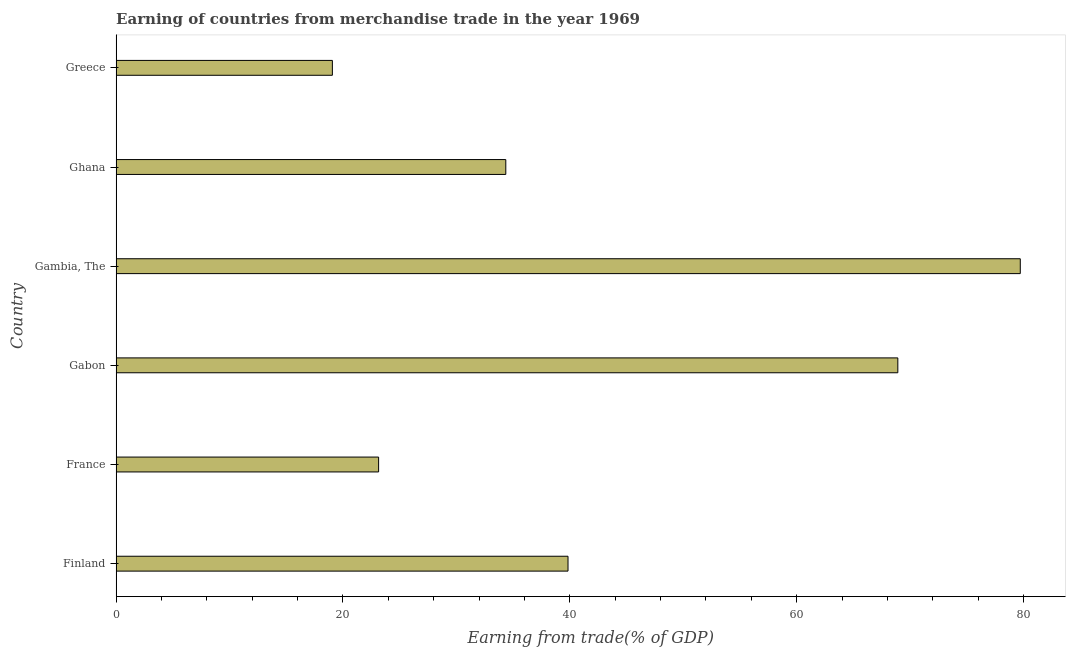Does the graph contain any zero values?
Give a very brief answer. No. Does the graph contain grids?
Provide a succinct answer. No. What is the title of the graph?
Ensure brevity in your answer.  Earning of countries from merchandise trade in the year 1969. What is the label or title of the X-axis?
Offer a very short reply. Earning from trade(% of GDP). What is the earning from merchandise trade in Gambia, The?
Provide a short and direct response. 79.71. Across all countries, what is the maximum earning from merchandise trade?
Your answer should be very brief. 79.71. Across all countries, what is the minimum earning from merchandise trade?
Provide a short and direct response. 19.06. In which country was the earning from merchandise trade maximum?
Keep it short and to the point. Gambia, The. What is the sum of the earning from merchandise trade?
Offer a very short reply. 265.03. What is the difference between the earning from merchandise trade in France and Gabon?
Your answer should be compact. -45.78. What is the average earning from merchandise trade per country?
Your response must be concise. 44.17. What is the median earning from merchandise trade?
Provide a succinct answer. 37.1. In how many countries, is the earning from merchandise trade greater than 28 %?
Your response must be concise. 4. What is the ratio of the earning from merchandise trade in France to that in Gabon?
Provide a succinct answer. 0.34. Is the earning from merchandise trade in Gambia, The less than that in Greece?
Your answer should be very brief. No. Is the difference between the earning from merchandise trade in France and Gambia, The greater than the difference between any two countries?
Make the answer very short. No. What is the difference between the highest and the second highest earning from merchandise trade?
Make the answer very short. 10.8. What is the difference between the highest and the lowest earning from merchandise trade?
Offer a very short reply. 60.65. In how many countries, is the earning from merchandise trade greater than the average earning from merchandise trade taken over all countries?
Keep it short and to the point. 2. Are all the bars in the graph horizontal?
Provide a succinct answer. Yes. What is the difference between two consecutive major ticks on the X-axis?
Give a very brief answer. 20. Are the values on the major ticks of X-axis written in scientific E-notation?
Ensure brevity in your answer.  No. What is the Earning from trade(% of GDP) of Finland?
Give a very brief answer. 39.84. What is the Earning from trade(% of GDP) of France?
Make the answer very short. 23.14. What is the Earning from trade(% of GDP) of Gabon?
Offer a very short reply. 68.92. What is the Earning from trade(% of GDP) of Gambia, The?
Keep it short and to the point. 79.71. What is the Earning from trade(% of GDP) in Ghana?
Ensure brevity in your answer.  34.35. What is the Earning from trade(% of GDP) of Greece?
Your response must be concise. 19.06. What is the difference between the Earning from trade(% of GDP) in Finland and France?
Offer a terse response. 16.7. What is the difference between the Earning from trade(% of GDP) in Finland and Gabon?
Provide a succinct answer. -29.08. What is the difference between the Earning from trade(% of GDP) in Finland and Gambia, The?
Your answer should be very brief. -39.87. What is the difference between the Earning from trade(% of GDP) in Finland and Ghana?
Ensure brevity in your answer.  5.49. What is the difference between the Earning from trade(% of GDP) in Finland and Greece?
Provide a succinct answer. 20.78. What is the difference between the Earning from trade(% of GDP) in France and Gabon?
Your response must be concise. -45.78. What is the difference between the Earning from trade(% of GDP) in France and Gambia, The?
Ensure brevity in your answer.  -56.57. What is the difference between the Earning from trade(% of GDP) in France and Ghana?
Keep it short and to the point. -11.21. What is the difference between the Earning from trade(% of GDP) in France and Greece?
Your response must be concise. 4.08. What is the difference between the Earning from trade(% of GDP) in Gabon and Gambia, The?
Give a very brief answer. -10.8. What is the difference between the Earning from trade(% of GDP) in Gabon and Ghana?
Keep it short and to the point. 34.56. What is the difference between the Earning from trade(% of GDP) in Gabon and Greece?
Provide a succinct answer. 49.85. What is the difference between the Earning from trade(% of GDP) in Gambia, The and Ghana?
Keep it short and to the point. 45.36. What is the difference between the Earning from trade(% of GDP) in Gambia, The and Greece?
Your response must be concise. 60.65. What is the difference between the Earning from trade(% of GDP) in Ghana and Greece?
Give a very brief answer. 15.29. What is the ratio of the Earning from trade(% of GDP) in Finland to that in France?
Provide a succinct answer. 1.72. What is the ratio of the Earning from trade(% of GDP) in Finland to that in Gabon?
Provide a succinct answer. 0.58. What is the ratio of the Earning from trade(% of GDP) in Finland to that in Ghana?
Your answer should be very brief. 1.16. What is the ratio of the Earning from trade(% of GDP) in Finland to that in Greece?
Ensure brevity in your answer.  2.09. What is the ratio of the Earning from trade(% of GDP) in France to that in Gabon?
Provide a succinct answer. 0.34. What is the ratio of the Earning from trade(% of GDP) in France to that in Gambia, The?
Offer a very short reply. 0.29. What is the ratio of the Earning from trade(% of GDP) in France to that in Ghana?
Provide a succinct answer. 0.67. What is the ratio of the Earning from trade(% of GDP) in France to that in Greece?
Keep it short and to the point. 1.21. What is the ratio of the Earning from trade(% of GDP) in Gabon to that in Gambia, The?
Ensure brevity in your answer.  0.86. What is the ratio of the Earning from trade(% of GDP) in Gabon to that in Ghana?
Provide a succinct answer. 2.01. What is the ratio of the Earning from trade(% of GDP) in Gabon to that in Greece?
Make the answer very short. 3.62. What is the ratio of the Earning from trade(% of GDP) in Gambia, The to that in Ghana?
Ensure brevity in your answer.  2.32. What is the ratio of the Earning from trade(% of GDP) in Gambia, The to that in Greece?
Keep it short and to the point. 4.18. What is the ratio of the Earning from trade(% of GDP) in Ghana to that in Greece?
Offer a terse response. 1.8. 